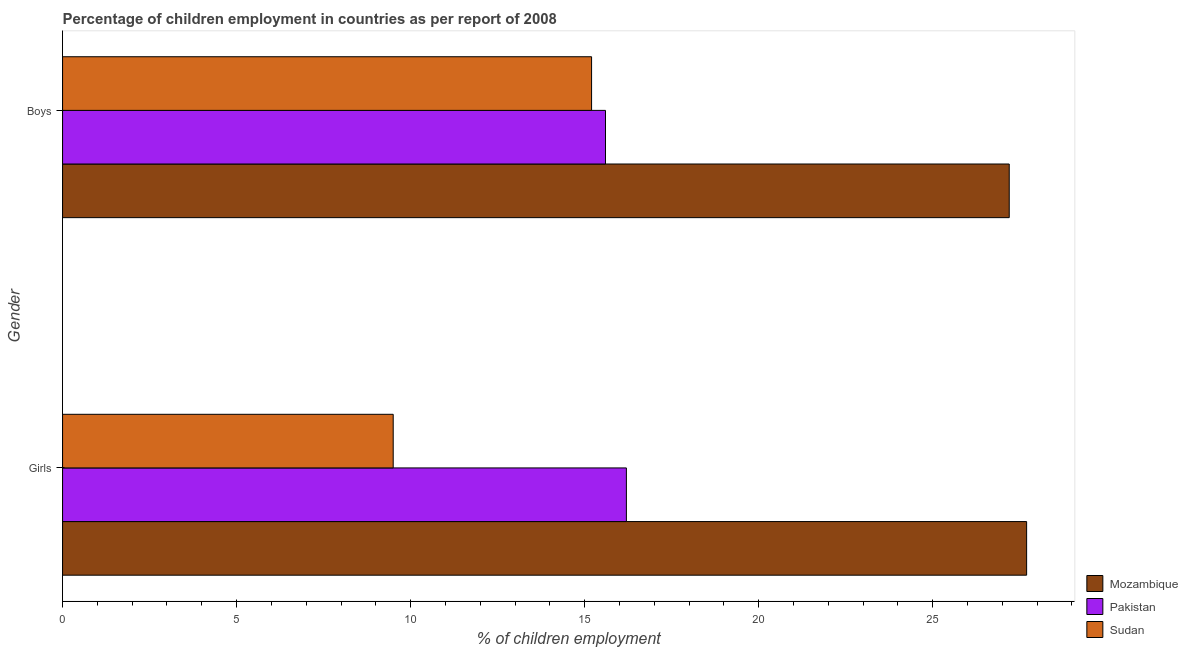How many groups of bars are there?
Offer a very short reply. 2. Are the number of bars per tick equal to the number of legend labels?
Ensure brevity in your answer.  Yes. Are the number of bars on each tick of the Y-axis equal?
Provide a short and direct response. Yes. What is the label of the 1st group of bars from the top?
Ensure brevity in your answer.  Boys. Across all countries, what is the maximum percentage of employed girls?
Offer a very short reply. 27.7. In which country was the percentage of employed boys maximum?
Keep it short and to the point. Mozambique. In which country was the percentage of employed boys minimum?
Give a very brief answer. Sudan. What is the total percentage of employed girls in the graph?
Your answer should be very brief. 53.4. What is the difference between the percentage of employed girls in Sudan and that in Mozambique?
Offer a very short reply. -18.2. What is the difference between the percentage of employed girls in Sudan and the percentage of employed boys in Mozambique?
Your answer should be very brief. -17.7. What is the average percentage of employed girls per country?
Your response must be concise. 17.8. What is the difference between the percentage of employed boys and percentage of employed girls in Pakistan?
Your response must be concise. -0.6. What is the ratio of the percentage of employed girls in Mozambique to that in Sudan?
Your response must be concise. 2.92. What does the 3rd bar from the top in Boys represents?
Make the answer very short. Mozambique. What does the 1st bar from the bottom in Boys represents?
Your answer should be compact. Mozambique. How many bars are there?
Offer a very short reply. 6. How many countries are there in the graph?
Your answer should be compact. 3. What is the difference between two consecutive major ticks on the X-axis?
Offer a terse response. 5. Where does the legend appear in the graph?
Keep it short and to the point. Bottom right. How many legend labels are there?
Keep it short and to the point. 3. How are the legend labels stacked?
Make the answer very short. Vertical. What is the title of the graph?
Your response must be concise. Percentage of children employment in countries as per report of 2008. Does "Jordan" appear as one of the legend labels in the graph?
Offer a very short reply. No. What is the label or title of the X-axis?
Your response must be concise. % of children employment. What is the % of children employment in Mozambique in Girls?
Your response must be concise. 27.7. What is the % of children employment in Pakistan in Girls?
Provide a short and direct response. 16.2. What is the % of children employment of Sudan in Girls?
Keep it short and to the point. 9.5. What is the % of children employment in Mozambique in Boys?
Give a very brief answer. 27.2. Across all Gender, what is the maximum % of children employment of Mozambique?
Your answer should be compact. 27.7. Across all Gender, what is the maximum % of children employment of Pakistan?
Your answer should be very brief. 16.2. Across all Gender, what is the maximum % of children employment in Sudan?
Keep it short and to the point. 15.2. Across all Gender, what is the minimum % of children employment in Mozambique?
Keep it short and to the point. 27.2. Across all Gender, what is the minimum % of children employment of Pakistan?
Give a very brief answer. 15.6. What is the total % of children employment of Mozambique in the graph?
Your answer should be compact. 54.9. What is the total % of children employment in Pakistan in the graph?
Your response must be concise. 31.8. What is the total % of children employment of Sudan in the graph?
Make the answer very short. 24.7. What is the difference between the % of children employment of Sudan in Girls and that in Boys?
Provide a succinct answer. -5.7. What is the average % of children employment of Mozambique per Gender?
Provide a succinct answer. 27.45. What is the average % of children employment of Pakistan per Gender?
Your answer should be compact. 15.9. What is the average % of children employment of Sudan per Gender?
Keep it short and to the point. 12.35. What is the difference between the % of children employment in Mozambique and % of children employment in Pakistan in Girls?
Ensure brevity in your answer.  11.5. What is the difference between the % of children employment in Mozambique and % of children employment in Sudan in Girls?
Give a very brief answer. 18.2. What is the difference between the % of children employment in Pakistan and % of children employment in Sudan in Girls?
Give a very brief answer. 6.7. What is the ratio of the % of children employment of Mozambique in Girls to that in Boys?
Provide a succinct answer. 1.02. What is the ratio of the % of children employment in Sudan in Girls to that in Boys?
Provide a short and direct response. 0.62. What is the difference between the highest and the second highest % of children employment of Mozambique?
Make the answer very short. 0.5. What is the difference between the highest and the second highest % of children employment in Pakistan?
Give a very brief answer. 0.6. What is the difference between the highest and the lowest % of children employment of Pakistan?
Your answer should be compact. 0.6. What is the difference between the highest and the lowest % of children employment of Sudan?
Your answer should be very brief. 5.7. 